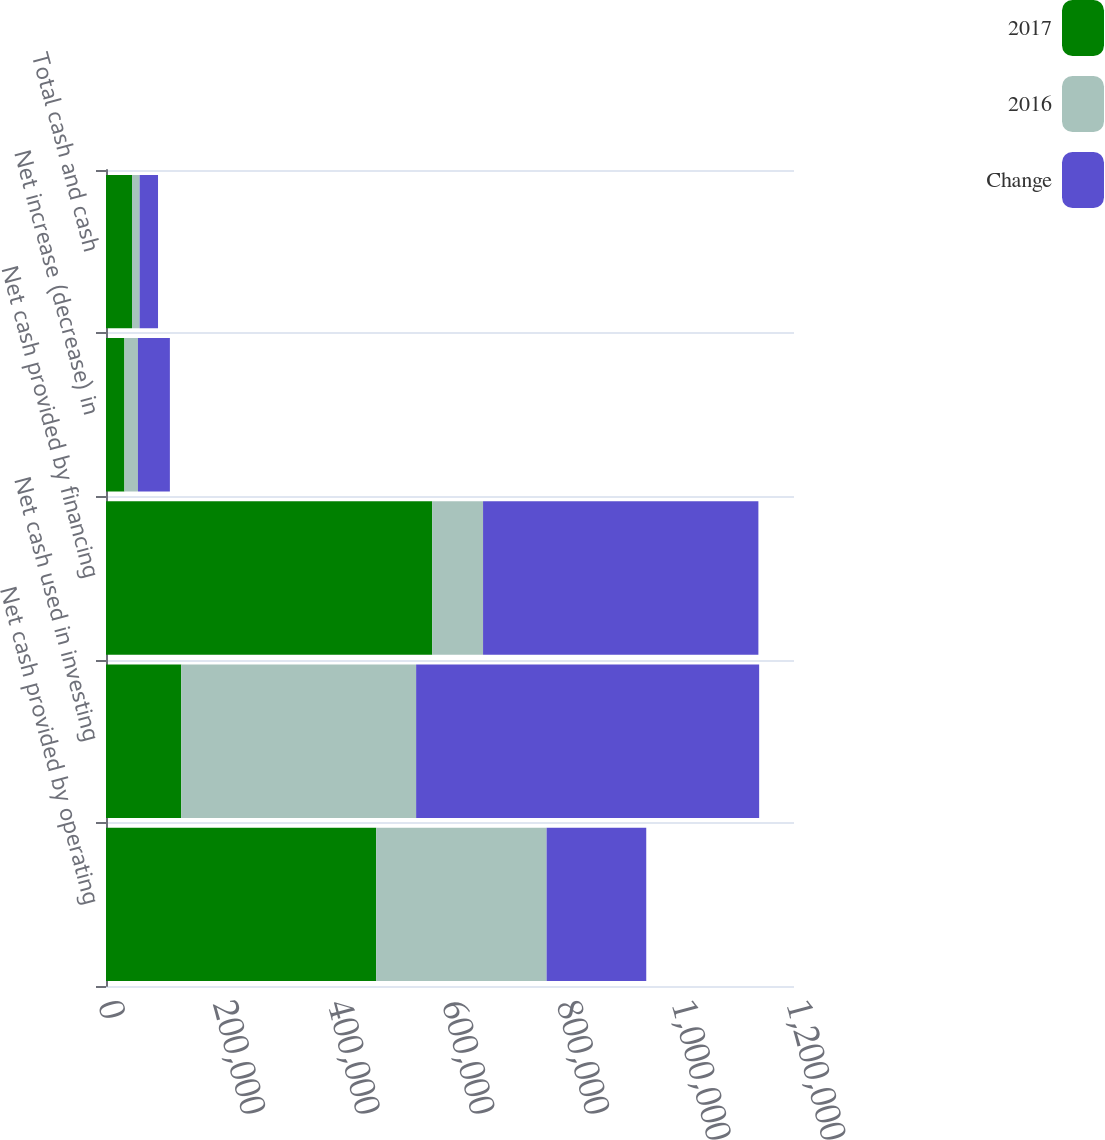Convert chart to OTSL. <chart><loc_0><loc_0><loc_500><loc_500><stacked_bar_chart><ecel><fcel>Net cash provided by operating<fcel>Net cash used in investing<fcel>Net cash provided by financing<fcel>Net increase (decrease) in<fcel>Total cash and cash<nl><fcel>2017<fcel>471146<fcel>131248<fcel>568948<fcel>32114<fcel>45370<nl><fcel>2016<fcel>297360<fcel>409671<fcel>88711<fcel>23600<fcel>13256<nl><fcel>Change<fcel>173786<fcel>598309<fcel>480237<fcel>55714<fcel>32114<nl></chart> 